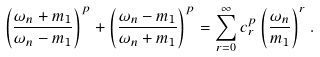<formula> <loc_0><loc_0><loc_500><loc_500>\left ( \frac { \omega _ { n } + m _ { 1 } } { \omega _ { n } - m _ { 1 } } \right ) ^ { p } + \left ( \frac { \omega _ { n } - m _ { 1 } } { \omega _ { n } + m _ { 1 } } \right ) ^ { p } = \sum _ { r = 0 } ^ { \infty } c _ { r } ^ { p } \left ( \frac { \omega _ { n } } { m _ { 1 } } \right ) ^ { r } .</formula> 